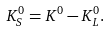Convert formula to latex. <formula><loc_0><loc_0><loc_500><loc_500>K ^ { 0 } _ { S } = K ^ { 0 } - K ^ { 0 } _ { L } .</formula> 